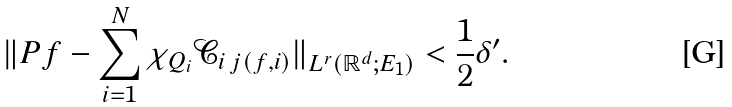Convert formula to latex. <formula><loc_0><loc_0><loc_500><loc_500>\| P f - \sum _ { i = 1 } ^ { N } \chi _ { Q _ { i } } \mathcal { C } _ { i \, j ( f , i ) } \| _ { L ^ { r } ( \mathbb { R } ^ { d } ; E _ { 1 } ) } < \frac { 1 } { 2 } \delta ^ { \prime } .</formula> 